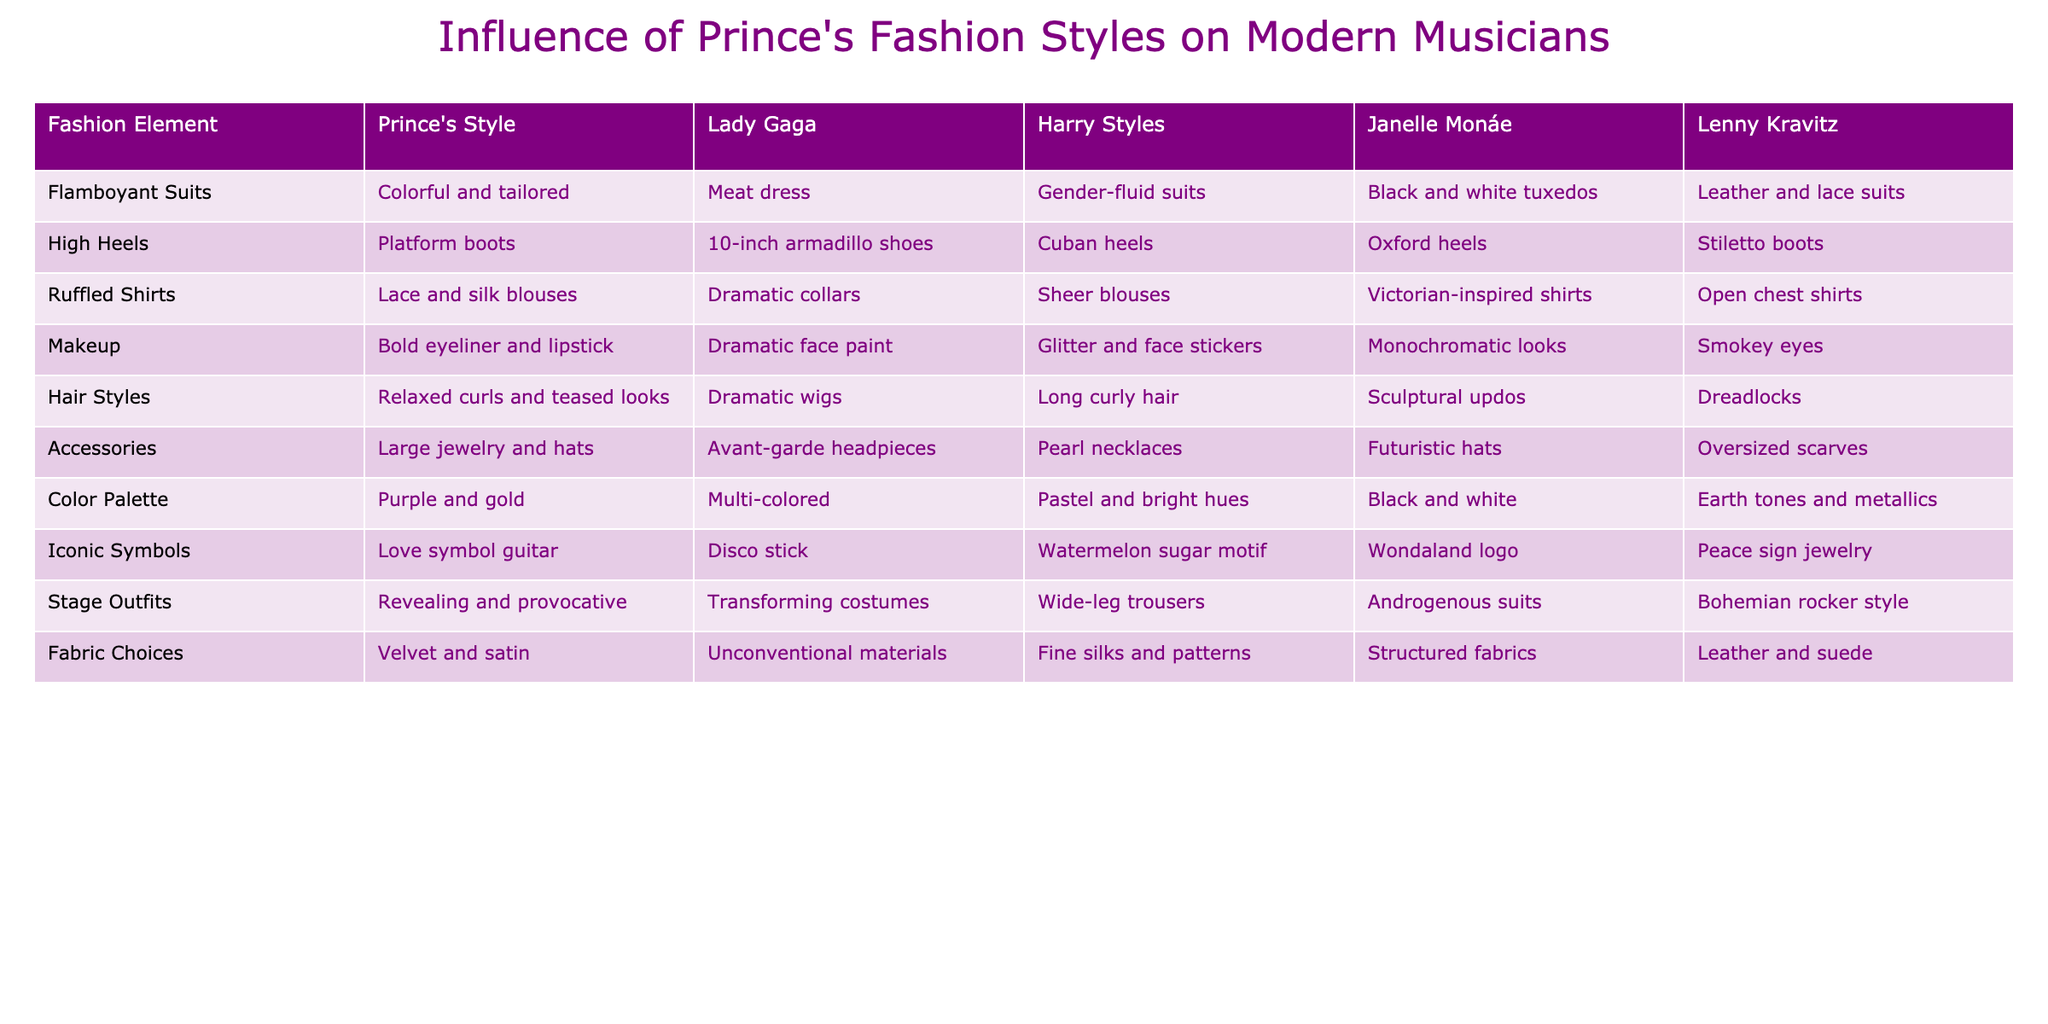What fashion element is associated with Prince's style and Janelle Monáe? Referring to the table, both Prince's style and Janelle Monáe's style feature ruffled shirts, specifically noting the types: Prince has lace and silk blouses while Monáe has Victorian-inspired shirts.
Answer: Ruffled shirts Which musician wears platform boots that are inspired by Prince's high heel style? According to the table, Lady Gaga is noted for wearing 10-inch armadillo shoes, which are similar to the platform boots that Prince wore, as both exhibit bold high heel footwear.
Answer: Lady Gaga Do all musicians in the table use dramatic makeup styles? Examining the table, it's evident that while Prince and Lady Gaga use dramatic makeup, others like Harry Styles and Janelle Monáe have their distinctive styles that may not be labeled as 'dramatic.' Thus, not all musicians use dramatic makeup.
Answer: No What is the color palette of Harry Styles, and how does it compare to Prince's color palette? Harry Styles' color palette is listed as pastel and bright hues, which differs significantly from Prince's purple and gold, indicating a preference for softer colors rather than the bold, deeper tones associated with Prince.
Answer: Pastel and bright hues Calculate the number of unique fashion elements featured in the table. The table lists 10 unique fashion elements, with each element corresponding to a fashion style represented by all musicians. Thus, the total number of unique elements is simply the count of the rows in the table.
Answer: 10 Who shares the common theme of avant-garde headpieces in their accessories with Prince? The table shows that both Prince and Lady Gaga have avant-garde headpieces as a part of their style, indicating a shared theme of bold and imaginative fashion in terms of accessories.
Answer: Lady Gaga Does Prince's fashion style heavily influence Harry Styles? Analyzing the similarities, Harry Styles' flamboyant approach and gender-fluid suits suggest influence, but not directly imitating; therefore, while there are overlaps, the influence may vary in style interpretation.
Answer: Yes Which musician has the most diverse fabric choices compared to Prince? In the table, Lady Gaga’s unconventional materials stand out as being more diverse than Prince’s choice of velvet and satin, showing an inclination towards a wider array of fabric textures and combinations.
Answer: Lady Gaga 